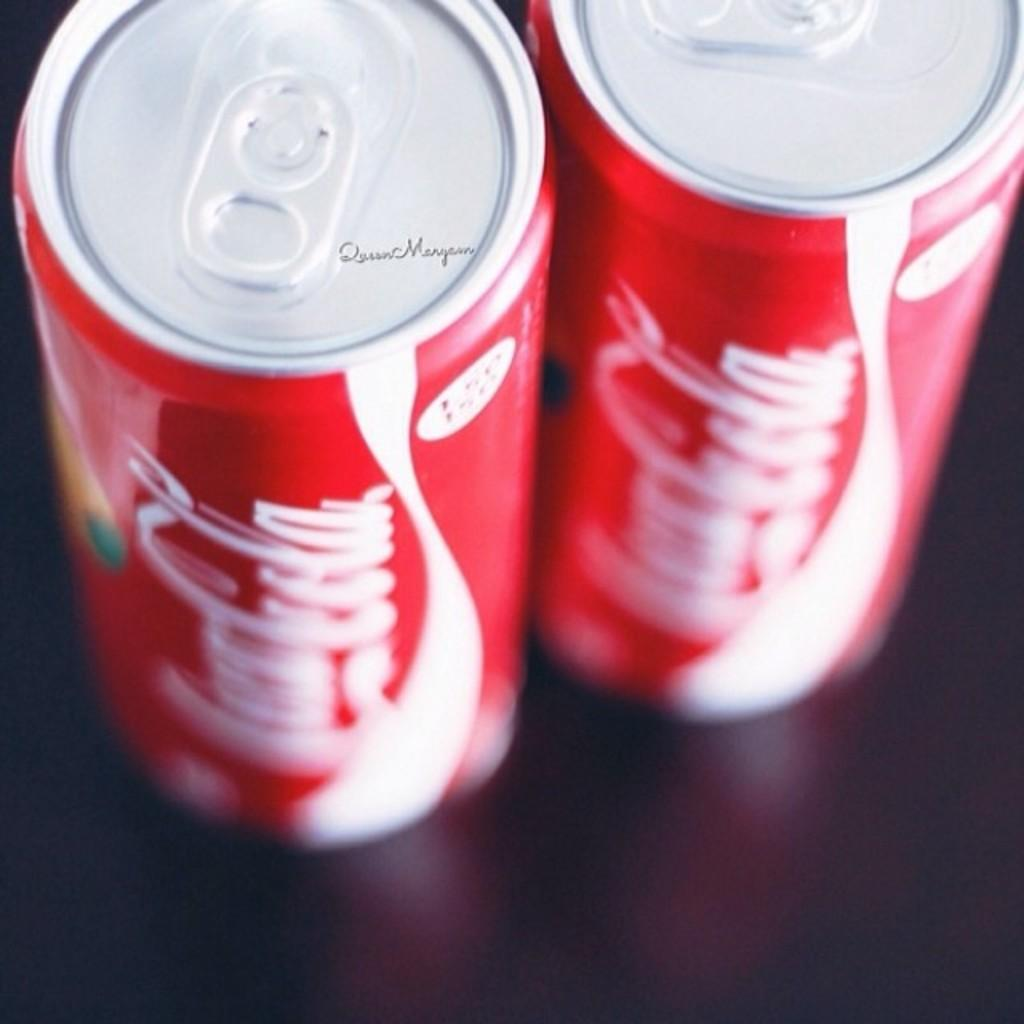<image>
Summarize the visual content of the image. Two cans of Coca-cola sit next to each other. 